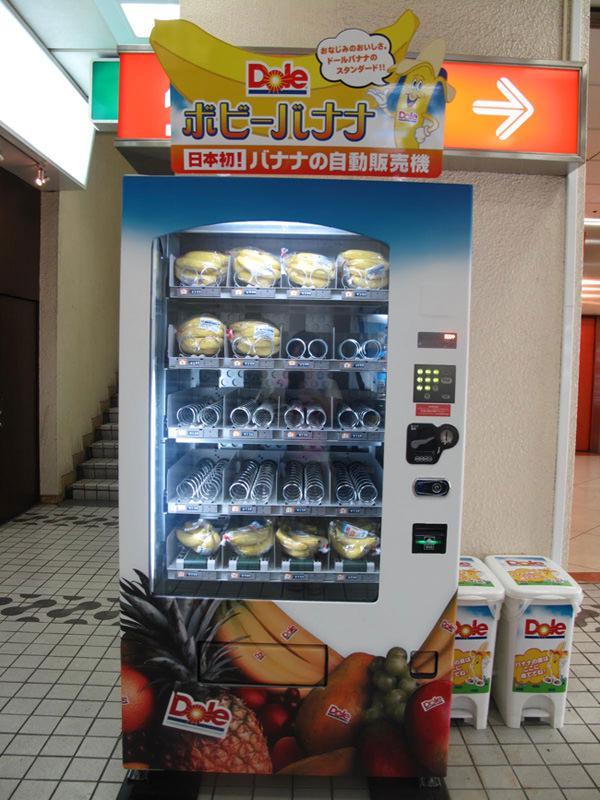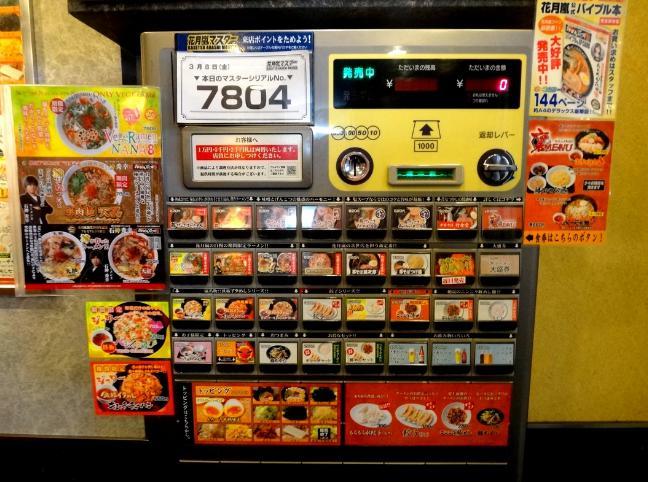The first image is the image on the left, the second image is the image on the right. Given the left and right images, does the statement "There are three beverage vending machines in one of the images." hold true? Answer yes or no. No. The first image is the image on the left, the second image is the image on the right. Considering the images on both sides, is "A trio of vending machines includes at least one red one." valid? Answer yes or no. No. 